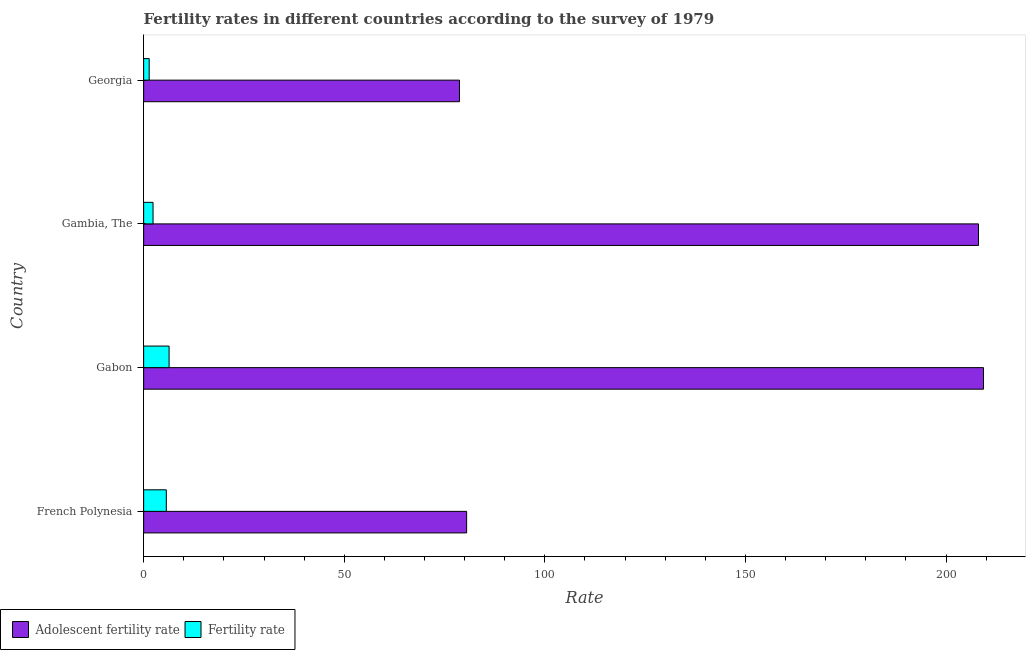Are the number of bars on each tick of the Y-axis equal?
Provide a succinct answer. Yes. How many bars are there on the 4th tick from the top?
Your response must be concise. 2. What is the label of the 4th group of bars from the top?
Keep it short and to the point. French Polynesia. What is the adolescent fertility rate in Georgia?
Offer a terse response. 78.72. Across all countries, what is the maximum fertility rate?
Offer a terse response. 6.34. Across all countries, what is the minimum fertility rate?
Provide a succinct answer. 1.38. In which country was the adolescent fertility rate maximum?
Make the answer very short. Gabon. In which country was the adolescent fertility rate minimum?
Provide a short and direct response. Georgia. What is the total fertility rate in the graph?
Offer a very short reply. 15.71. What is the difference between the fertility rate in Gambia, The and the adolescent fertility rate in Georgia?
Provide a succinct answer. -76.38. What is the average fertility rate per country?
Provide a succinct answer. 3.93. What is the difference between the fertility rate and adolescent fertility rate in Georgia?
Give a very brief answer. -77.34. In how many countries, is the adolescent fertility rate greater than 100 ?
Your response must be concise. 2. What is the ratio of the adolescent fertility rate in Gambia, The to that in Georgia?
Offer a terse response. 2.64. What is the difference between the highest and the second highest fertility rate?
Your answer should be very brief. 0.69. What is the difference between the highest and the lowest fertility rate?
Your answer should be compact. 4.96. In how many countries, is the adolescent fertility rate greater than the average adolescent fertility rate taken over all countries?
Keep it short and to the point. 2. What does the 1st bar from the top in French Polynesia represents?
Keep it short and to the point. Fertility rate. What does the 1st bar from the bottom in Georgia represents?
Provide a short and direct response. Adolescent fertility rate. How many bars are there?
Give a very brief answer. 8. How many countries are there in the graph?
Give a very brief answer. 4. How are the legend labels stacked?
Give a very brief answer. Horizontal. What is the title of the graph?
Ensure brevity in your answer.  Fertility rates in different countries according to the survey of 1979. Does "Non-resident workers" appear as one of the legend labels in the graph?
Ensure brevity in your answer.  No. What is the label or title of the X-axis?
Provide a short and direct response. Rate. What is the label or title of the Y-axis?
Give a very brief answer. Country. What is the Rate of Adolescent fertility rate in French Polynesia?
Make the answer very short. 80.5. What is the Rate of Fertility rate in French Polynesia?
Your answer should be compact. 5.65. What is the Rate in Adolescent fertility rate in Gabon?
Offer a terse response. 209.33. What is the Rate in Fertility rate in Gabon?
Make the answer very short. 6.34. What is the Rate of Adolescent fertility rate in Gambia, The?
Give a very brief answer. 208.09. What is the Rate of Fertility rate in Gambia, The?
Provide a succinct answer. 2.34. What is the Rate in Adolescent fertility rate in Georgia?
Give a very brief answer. 78.72. What is the Rate of Fertility rate in Georgia?
Provide a short and direct response. 1.38. Across all countries, what is the maximum Rate of Adolescent fertility rate?
Your response must be concise. 209.33. Across all countries, what is the maximum Rate in Fertility rate?
Ensure brevity in your answer.  6.34. Across all countries, what is the minimum Rate in Adolescent fertility rate?
Offer a very short reply. 78.72. Across all countries, what is the minimum Rate of Fertility rate?
Keep it short and to the point. 1.38. What is the total Rate in Adolescent fertility rate in the graph?
Your response must be concise. 576.65. What is the total Rate of Fertility rate in the graph?
Offer a very short reply. 15.71. What is the difference between the Rate of Adolescent fertility rate in French Polynesia and that in Gabon?
Provide a short and direct response. -128.83. What is the difference between the Rate in Fertility rate in French Polynesia and that in Gabon?
Your answer should be compact. -0.69. What is the difference between the Rate of Adolescent fertility rate in French Polynesia and that in Gambia, The?
Your response must be concise. -127.59. What is the difference between the Rate in Fertility rate in French Polynesia and that in Gambia, The?
Provide a succinct answer. 3.31. What is the difference between the Rate in Adolescent fertility rate in French Polynesia and that in Georgia?
Make the answer very short. 1.78. What is the difference between the Rate of Fertility rate in French Polynesia and that in Georgia?
Keep it short and to the point. 4.27. What is the difference between the Rate in Adolescent fertility rate in Gabon and that in Gambia, The?
Make the answer very short. 1.25. What is the difference between the Rate of Fertility rate in Gabon and that in Gambia, The?
Provide a succinct answer. 4. What is the difference between the Rate in Adolescent fertility rate in Gabon and that in Georgia?
Provide a succinct answer. 130.61. What is the difference between the Rate of Fertility rate in Gabon and that in Georgia?
Your response must be concise. 4.96. What is the difference between the Rate in Adolescent fertility rate in Gambia, The and that in Georgia?
Provide a succinct answer. 129.36. What is the difference between the Rate of Adolescent fertility rate in French Polynesia and the Rate of Fertility rate in Gabon?
Give a very brief answer. 74.16. What is the difference between the Rate in Adolescent fertility rate in French Polynesia and the Rate in Fertility rate in Gambia, The?
Provide a short and direct response. 78.16. What is the difference between the Rate of Adolescent fertility rate in French Polynesia and the Rate of Fertility rate in Georgia?
Offer a very short reply. 79.12. What is the difference between the Rate in Adolescent fertility rate in Gabon and the Rate in Fertility rate in Gambia, The?
Your answer should be very brief. 206.99. What is the difference between the Rate in Adolescent fertility rate in Gabon and the Rate in Fertility rate in Georgia?
Your answer should be very brief. 207.95. What is the difference between the Rate in Adolescent fertility rate in Gambia, The and the Rate in Fertility rate in Georgia?
Your answer should be very brief. 206.71. What is the average Rate of Adolescent fertility rate per country?
Provide a short and direct response. 144.16. What is the average Rate of Fertility rate per country?
Offer a terse response. 3.93. What is the difference between the Rate in Adolescent fertility rate and Rate in Fertility rate in French Polynesia?
Ensure brevity in your answer.  74.86. What is the difference between the Rate of Adolescent fertility rate and Rate of Fertility rate in Gabon?
Keep it short and to the point. 202.99. What is the difference between the Rate in Adolescent fertility rate and Rate in Fertility rate in Gambia, The?
Ensure brevity in your answer.  205.75. What is the difference between the Rate of Adolescent fertility rate and Rate of Fertility rate in Georgia?
Make the answer very short. 77.34. What is the ratio of the Rate of Adolescent fertility rate in French Polynesia to that in Gabon?
Keep it short and to the point. 0.38. What is the ratio of the Rate of Fertility rate in French Polynesia to that in Gabon?
Offer a very short reply. 0.89. What is the ratio of the Rate of Adolescent fertility rate in French Polynesia to that in Gambia, The?
Ensure brevity in your answer.  0.39. What is the ratio of the Rate of Fertility rate in French Polynesia to that in Gambia, The?
Ensure brevity in your answer.  2.41. What is the ratio of the Rate in Adolescent fertility rate in French Polynesia to that in Georgia?
Your response must be concise. 1.02. What is the ratio of the Rate of Fertility rate in French Polynesia to that in Georgia?
Provide a succinct answer. 4.09. What is the ratio of the Rate of Adolescent fertility rate in Gabon to that in Gambia, The?
Give a very brief answer. 1.01. What is the ratio of the Rate in Fertility rate in Gabon to that in Gambia, The?
Offer a very short reply. 2.71. What is the ratio of the Rate in Adolescent fertility rate in Gabon to that in Georgia?
Keep it short and to the point. 2.66. What is the ratio of the Rate in Fertility rate in Gabon to that in Georgia?
Your answer should be compact. 4.6. What is the ratio of the Rate of Adolescent fertility rate in Gambia, The to that in Georgia?
Your answer should be compact. 2.64. What is the ratio of the Rate of Fertility rate in Gambia, The to that in Georgia?
Your answer should be compact. 1.7. What is the difference between the highest and the second highest Rate in Adolescent fertility rate?
Your response must be concise. 1.25. What is the difference between the highest and the second highest Rate in Fertility rate?
Offer a terse response. 0.69. What is the difference between the highest and the lowest Rate of Adolescent fertility rate?
Your response must be concise. 130.61. What is the difference between the highest and the lowest Rate of Fertility rate?
Give a very brief answer. 4.96. 